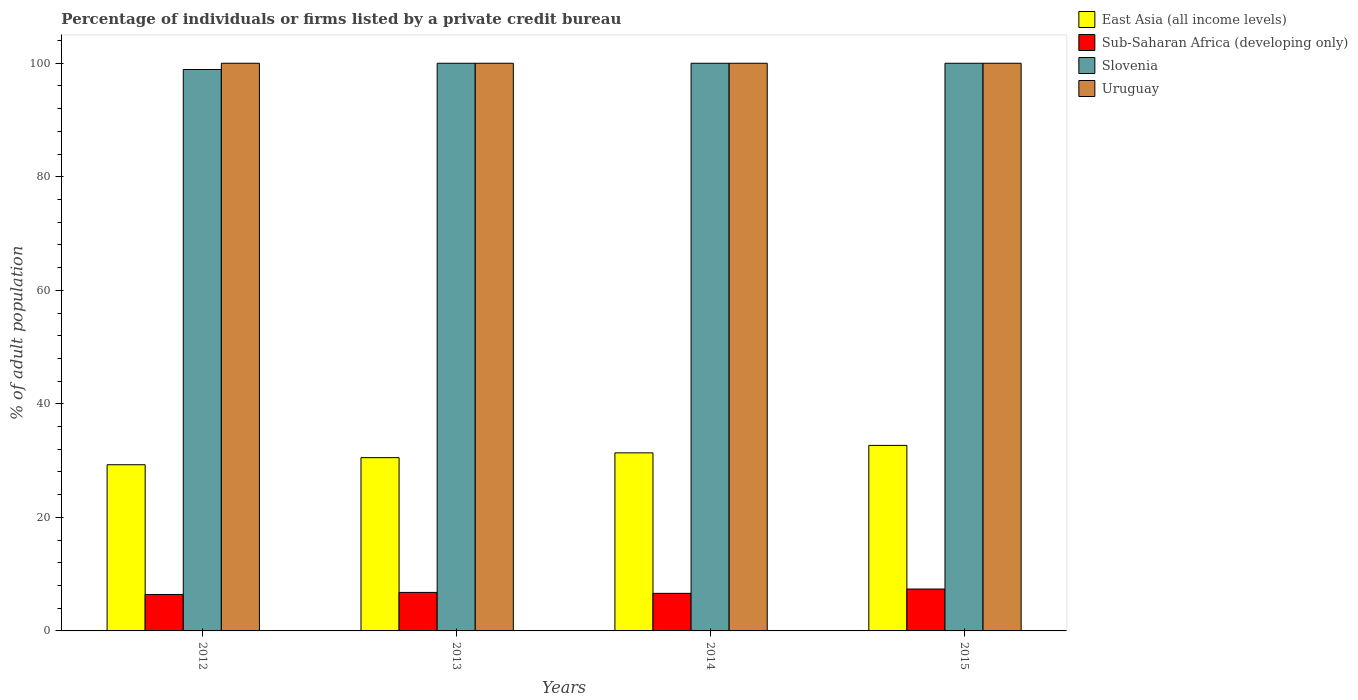How many groups of bars are there?
Provide a succinct answer. 4. Are the number of bars per tick equal to the number of legend labels?
Your answer should be very brief. Yes. How many bars are there on the 1st tick from the right?
Your response must be concise. 4. In how many cases, is the number of bars for a given year not equal to the number of legend labels?
Offer a terse response. 0. What is the percentage of population listed by a private credit bureau in Slovenia in 2014?
Provide a short and direct response. 100. Across all years, what is the minimum percentage of population listed by a private credit bureau in Slovenia?
Offer a terse response. 98.9. What is the total percentage of population listed by a private credit bureau in East Asia (all income levels) in the graph?
Offer a very short reply. 123.85. What is the difference between the percentage of population listed by a private credit bureau in Sub-Saharan Africa (developing only) in 2012 and that in 2015?
Ensure brevity in your answer.  -0.96. What is the difference between the percentage of population listed by a private credit bureau in Uruguay in 2012 and the percentage of population listed by a private credit bureau in Slovenia in 2013?
Offer a very short reply. 0. What is the average percentage of population listed by a private credit bureau in Sub-Saharan Africa (developing only) per year?
Your response must be concise. 6.8. In the year 2014, what is the difference between the percentage of population listed by a private credit bureau in Uruguay and percentage of population listed by a private credit bureau in Sub-Saharan Africa (developing only)?
Your response must be concise. 93.38. In how many years, is the percentage of population listed by a private credit bureau in Slovenia greater than 80 %?
Your answer should be compact. 4. What is the ratio of the percentage of population listed by a private credit bureau in Sub-Saharan Africa (developing only) in 2012 to that in 2015?
Your answer should be compact. 0.87. What is the difference between the highest and the lowest percentage of population listed by a private credit bureau in East Asia (all income levels)?
Give a very brief answer. 3.41. Is it the case that in every year, the sum of the percentage of population listed by a private credit bureau in Slovenia and percentage of population listed by a private credit bureau in Sub-Saharan Africa (developing only) is greater than the sum of percentage of population listed by a private credit bureau in Uruguay and percentage of population listed by a private credit bureau in East Asia (all income levels)?
Offer a terse response. Yes. What does the 4th bar from the left in 2015 represents?
Give a very brief answer. Uruguay. What does the 4th bar from the right in 2012 represents?
Keep it short and to the point. East Asia (all income levels). How many bars are there?
Your answer should be very brief. 16. How many years are there in the graph?
Provide a succinct answer. 4. What is the difference between two consecutive major ticks on the Y-axis?
Provide a succinct answer. 20. Are the values on the major ticks of Y-axis written in scientific E-notation?
Your answer should be compact. No. Does the graph contain any zero values?
Ensure brevity in your answer.  No. Does the graph contain grids?
Your answer should be compact. No. Where does the legend appear in the graph?
Offer a terse response. Top right. How many legend labels are there?
Provide a short and direct response. 4. What is the title of the graph?
Offer a very short reply. Percentage of individuals or firms listed by a private credit bureau. What is the label or title of the Y-axis?
Your response must be concise. % of adult population. What is the % of adult population in East Asia (all income levels) in 2012?
Your answer should be very brief. 29.28. What is the % of adult population in Sub-Saharan Africa (developing only) in 2012?
Give a very brief answer. 6.42. What is the % of adult population in Slovenia in 2012?
Offer a very short reply. 98.9. What is the % of adult population in Uruguay in 2012?
Your response must be concise. 100. What is the % of adult population of East Asia (all income levels) in 2013?
Provide a short and direct response. 30.52. What is the % of adult population of Sub-Saharan Africa (developing only) in 2013?
Your answer should be compact. 6.78. What is the % of adult population of Slovenia in 2013?
Ensure brevity in your answer.  100. What is the % of adult population of Uruguay in 2013?
Your response must be concise. 100. What is the % of adult population of East Asia (all income levels) in 2014?
Your answer should be very brief. 31.37. What is the % of adult population in Sub-Saharan Africa (developing only) in 2014?
Keep it short and to the point. 6.62. What is the % of adult population in Slovenia in 2014?
Ensure brevity in your answer.  100. What is the % of adult population in Uruguay in 2014?
Make the answer very short. 100. What is the % of adult population in East Asia (all income levels) in 2015?
Offer a very short reply. 32.68. What is the % of adult population of Sub-Saharan Africa (developing only) in 2015?
Provide a short and direct response. 7.38. What is the % of adult population in Slovenia in 2015?
Make the answer very short. 100. Across all years, what is the maximum % of adult population of East Asia (all income levels)?
Give a very brief answer. 32.68. Across all years, what is the maximum % of adult population in Sub-Saharan Africa (developing only)?
Your response must be concise. 7.38. Across all years, what is the maximum % of adult population in Slovenia?
Offer a very short reply. 100. Across all years, what is the minimum % of adult population of East Asia (all income levels)?
Ensure brevity in your answer.  29.28. Across all years, what is the minimum % of adult population of Sub-Saharan Africa (developing only)?
Give a very brief answer. 6.42. Across all years, what is the minimum % of adult population of Slovenia?
Provide a succinct answer. 98.9. Across all years, what is the minimum % of adult population in Uruguay?
Give a very brief answer. 100. What is the total % of adult population in East Asia (all income levels) in the graph?
Your answer should be compact. 123.85. What is the total % of adult population of Sub-Saharan Africa (developing only) in the graph?
Make the answer very short. 27.2. What is the total % of adult population in Slovenia in the graph?
Ensure brevity in your answer.  398.9. What is the difference between the % of adult population in East Asia (all income levels) in 2012 and that in 2013?
Give a very brief answer. -1.25. What is the difference between the % of adult population in Sub-Saharan Africa (developing only) in 2012 and that in 2013?
Keep it short and to the point. -0.36. What is the difference between the % of adult population in Uruguay in 2012 and that in 2013?
Provide a short and direct response. 0. What is the difference between the % of adult population in East Asia (all income levels) in 2012 and that in 2014?
Give a very brief answer. -2.09. What is the difference between the % of adult population of Sub-Saharan Africa (developing only) in 2012 and that in 2014?
Provide a short and direct response. -0.2. What is the difference between the % of adult population of Slovenia in 2012 and that in 2014?
Offer a very short reply. -1.1. What is the difference between the % of adult population of Uruguay in 2012 and that in 2014?
Provide a succinct answer. 0. What is the difference between the % of adult population of East Asia (all income levels) in 2012 and that in 2015?
Give a very brief answer. -3.41. What is the difference between the % of adult population of Sub-Saharan Africa (developing only) in 2012 and that in 2015?
Provide a short and direct response. -0.96. What is the difference between the % of adult population of East Asia (all income levels) in 2013 and that in 2014?
Your answer should be very brief. -0.84. What is the difference between the % of adult population in Sub-Saharan Africa (developing only) in 2013 and that in 2014?
Your response must be concise. 0.16. What is the difference between the % of adult population in Slovenia in 2013 and that in 2014?
Provide a short and direct response. 0. What is the difference between the % of adult population in East Asia (all income levels) in 2013 and that in 2015?
Your answer should be very brief. -2.16. What is the difference between the % of adult population of Sub-Saharan Africa (developing only) in 2013 and that in 2015?
Keep it short and to the point. -0.6. What is the difference between the % of adult population in Uruguay in 2013 and that in 2015?
Make the answer very short. 0. What is the difference between the % of adult population in East Asia (all income levels) in 2014 and that in 2015?
Your answer should be compact. -1.31. What is the difference between the % of adult population in Sub-Saharan Africa (developing only) in 2014 and that in 2015?
Your answer should be compact. -0.76. What is the difference between the % of adult population in Slovenia in 2014 and that in 2015?
Ensure brevity in your answer.  0. What is the difference between the % of adult population in Uruguay in 2014 and that in 2015?
Make the answer very short. 0. What is the difference between the % of adult population in East Asia (all income levels) in 2012 and the % of adult population in Sub-Saharan Africa (developing only) in 2013?
Your answer should be compact. 22.49. What is the difference between the % of adult population of East Asia (all income levels) in 2012 and the % of adult population of Slovenia in 2013?
Offer a terse response. -70.72. What is the difference between the % of adult population in East Asia (all income levels) in 2012 and the % of adult population in Uruguay in 2013?
Provide a succinct answer. -70.72. What is the difference between the % of adult population in Sub-Saharan Africa (developing only) in 2012 and the % of adult population in Slovenia in 2013?
Your answer should be compact. -93.58. What is the difference between the % of adult population in Sub-Saharan Africa (developing only) in 2012 and the % of adult population in Uruguay in 2013?
Provide a short and direct response. -93.58. What is the difference between the % of adult population of East Asia (all income levels) in 2012 and the % of adult population of Sub-Saharan Africa (developing only) in 2014?
Your answer should be compact. 22.66. What is the difference between the % of adult population in East Asia (all income levels) in 2012 and the % of adult population in Slovenia in 2014?
Provide a short and direct response. -70.72. What is the difference between the % of adult population in East Asia (all income levels) in 2012 and the % of adult population in Uruguay in 2014?
Your answer should be compact. -70.72. What is the difference between the % of adult population of Sub-Saharan Africa (developing only) in 2012 and the % of adult population of Slovenia in 2014?
Your response must be concise. -93.58. What is the difference between the % of adult population of Sub-Saharan Africa (developing only) in 2012 and the % of adult population of Uruguay in 2014?
Give a very brief answer. -93.58. What is the difference between the % of adult population in Slovenia in 2012 and the % of adult population in Uruguay in 2014?
Give a very brief answer. -1.1. What is the difference between the % of adult population of East Asia (all income levels) in 2012 and the % of adult population of Sub-Saharan Africa (developing only) in 2015?
Your answer should be compact. 21.9. What is the difference between the % of adult population in East Asia (all income levels) in 2012 and the % of adult population in Slovenia in 2015?
Keep it short and to the point. -70.72. What is the difference between the % of adult population of East Asia (all income levels) in 2012 and the % of adult population of Uruguay in 2015?
Provide a short and direct response. -70.72. What is the difference between the % of adult population in Sub-Saharan Africa (developing only) in 2012 and the % of adult population in Slovenia in 2015?
Make the answer very short. -93.58. What is the difference between the % of adult population of Sub-Saharan Africa (developing only) in 2012 and the % of adult population of Uruguay in 2015?
Ensure brevity in your answer.  -93.58. What is the difference between the % of adult population of Slovenia in 2012 and the % of adult population of Uruguay in 2015?
Give a very brief answer. -1.1. What is the difference between the % of adult population in East Asia (all income levels) in 2013 and the % of adult population in Sub-Saharan Africa (developing only) in 2014?
Provide a succinct answer. 23.91. What is the difference between the % of adult population of East Asia (all income levels) in 2013 and the % of adult population of Slovenia in 2014?
Offer a terse response. -69.48. What is the difference between the % of adult population in East Asia (all income levels) in 2013 and the % of adult population in Uruguay in 2014?
Make the answer very short. -69.48. What is the difference between the % of adult population of Sub-Saharan Africa (developing only) in 2013 and the % of adult population of Slovenia in 2014?
Your answer should be very brief. -93.22. What is the difference between the % of adult population in Sub-Saharan Africa (developing only) in 2013 and the % of adult population in Uruguay in 2014?
Your answer should be compact. -93.22. What is the difference between the % of adult population in East Asia (all income levels) in 2013 and the % of adult population in Sub-Saharan Africa (developing only) in 2015?
Your answer should be compact. 23.14. What is the difference between the % of adult population of East Asia (all income levels) in 2013 and the % of adult population of Slovenia in 2015?
Make the answer very short. -69.48. What is the difference between the % of adult population in East Asia (all income levels) in 2013 and the % of adult population in Uruguay in 2015?
Your response must be concise. -69.48. What is the difference between the % of adult population in Sub-Saharan Africa (developing only) in 2013 and the % of adult population in Slovenia in 2015?
Give a very brief answer. -93.22. What is the difference between the % of adult population in Sub-Saharan Africa (developing only) in 2013 and the % of adult population in Uruguay in 2015?
Provide a succinct answer. -93.22. What is the difference between the % of adult population in East Asia (all income levels) in 2014 and the % of adult population in Sub-Saharan Africa (developing only) in 2015?
Your response must be concise. 23.99. What is the difference between the % of adult population of East Asia (all income levels) in 2014 and the % of adult population of Slovenia in 2015?
Keep it short and to the point. -68.63. What is the difference between the % of adult population of East Asia (all income levels) in 2014 and the % of adult population of Uruguay in 2015?
Provide a succinct answer. -68.63. What is the difference between the % of adult population in Sub-Saharan Africa (developing only) in 2014 and the % of adult population in Slovenia in 2015?
Ensure brevity in your answer.  -93.38. What is the difference between the % of adult population of Sub-Saharan Africa (developing only) in 2014 and the % of adult population of Uruguay in 2015?
Make the answer very short. -93.38. What is the difference between the % of adult population in Slovenia in 2014 and the % of adult population in Uruguay in 2015?
Give a very brief answer. 0. What is the average % of adult population in East Asia (all income levels) per year?
Offer a very short reply. 30.96. What is the average % of adult population of Sub-Saharan Africa (developing only) per year?
Your answer should be compact. 6.8. What is the average % of adult population of Slovenia per year?
Provide a succinct answer. 99.72. In the year 2012, what is the difference between the % of adult population of East Asia (all income levels) and % of adult population of Sub-Saharan Africa (developing only)?
Give a very brief answer. 22.86. In the year 2012, what is the difference between the % of adult population of East Asia (all income levels) and % of adult population of Slovenia?
Your answer should be compact. -69.62. In the year 2012, what is the difference between the % of adult population in East Asia (all income levels) and % of adult population in Uruguay?
Make the answer very short. -70.72. In the year 2012, what is the difference between the % of adult population in Sub-Saharan Africa (developing only) and % of adult population in Slovenia?
Keep it short and to the point. -92.48. In the year 2012, what is the difference between the % of adult population of Sub-Saharan Africa (developing only) and % of adult population of Uruguay?
Ensure brevity in your answer.  -93.58. In the year 2013, what is the difference between the % of adult population in East Asia (all income levels) and % of adult population in Sub-Saharan Africa (developing only)?
Offer a very short reply. 23.74. In the year 2013, what is the difference between the % of adult population of East Asia (all income levels) and % of adult population of Slovenia?
Your response must be concise. -69.48. In the year 2013, what is the difference between the % of adult population in East Asia (all income levels) and % of adult population in Uruguay?
Offer a terse response. -69.48. In the year 2013, what is the difference between the % of adult population of Sub-Saharan Africa (developing only) and % of adult population of Slovenia?
Your answer should be compact. -93.22. In the year 2013, what is the difference between the % of adult population in Sub-Saharan Africa (developing only) and % of adult population in Uruguay?
Your answer should be very brief. -93.22. In the year 2013, what is the difference between the % of adult population of Slovenia and % of adult population of Uruguay?
Offer a terse response. 0. In the year 2014, what is the difference between the % of adult population of East Asia (all income levels) and % of adult population of Sub-Saharan Africa (developing only)?
Your answer should be very brief. 24.75. In the year 2014, what is the difference between the % of adult population of East Asia (all income levels) and % of adult population of Slovenia?
Make the answer very short. -68.63. In the year 2014, what is the difference between the % of adult population in East Asia (all income levels) and % of adult population in Uruguay?
Offer a terse response. -68.63. In the year 2014, what is the difference between the % of adult population of Sub-Saharan Africa (developing only) and % of adult population of Slovenia?
Your response must be concise. -93.38. In the year 2014, what is the difference between the % of adult population in Sub-Saharan Africa (developing only) and % of adult population in Uruguay?
Your answer should be very brief. -93.38. In the year 2014, what is the difference between the % of adult population of Slovenia and % of adult population of Uruguay?
Keep it short and to the point. 0. In the year 2015, what is the difference between the % of adult population in East Asia (all income levels) and % of adult population in Sub-Saharan Africa (developing only)?
Offer a very short reply. 25.3. In the year 2015, what is the difference between the % of adult population in East Asia (all income levels) and % of adult population in Slovenia?
Ensure brevity in your answer.  -67.32. In the year 2015, what is the difference between the % of adult population in East Asia (all income levels) and % of adult population in Uruguay?
Provide a succinct answer. -67.32. In the year 2015, what is the difference between the % of adult population of Sub-Saharan Africa (developing only) and % of adult population of Slovenia?
Keep it short and to the point. -92.62. In the year 2015, what is the difference between the % of adult population in Sub-Saharan Africa (developing only) and % of adult population in Uruguay?
Provide a succinct answer. -92.62. In the year 2015, what is the difference between the % of adult population in Slovenia and % of adult population in Uruguay?
Provide a succinct answer. 0. What is the ratio of the % of adult population of East Asia (all income levels) in 2012 to that in 2013?
Your answer should be compact. 0.96. What is the ratio of the % of adult population in Sub-Saharan Africa (developing only) in 2012 to that in 2013?
Offer a very short reply. 0.95. What is the ratio of the % of adult population of Sub-Saharan Africa (developing only) in 2012 to that in 2014?
Make the answer very short. 0.97. What is the ratio of the % of adult population in Uruguay in 2012 to that in 2014?
Offer a very short reply. 1. What is the ratio of the % of adult population in East Asia (all income levels) in 2012 to that in 2015?
Ensure brevity in your answer.  0.9. What is the ratio of the % of adult population in Sub-Saharan Africa (developing only) in 2012 to that in 2015?
Your response must be concise. 0.87. What is the ratio of the % of adult population of Slovenia in 2012 to that in 2015?
Your response must be concise. 0.99. What is the ratio of the % of adult population in Uruguay in 2012 to that in 2015?
Make the answer very short. 1. What is the ratio of the % of adult population in East Asia (all income levels) in 2013 to that in 2014?
Offer a very short reply. 0.97. What is the ratio of the % of adult population of Sub-Saharan Africa (developing only) in 2013 to that in 2014?
Offer a terse response. 1.02. What is the ratio of the % of adult population in Uruguay in 2013 to that in 2014?
Make the answer very short. 1. What is the ratio of the % of adult population in East Asia (all income levels) in 2013 to that in 2015?
Provide a short and direct response. 0.93. What is the ratio of the % of adult population in Sub-Saharan Africa (developing only) in 2013 to that in 2015?
Your response must be concise. 0.92. What is the ratio of the % of adult population of Slovenia in 2013 to that in 2015?
Make the answer very short. 1. What is the ratio of the % of adult population in East Asia (all income levels) in 2014 to that in 2015?
Provide a short and direct response. 0.96. What is the ratio of the % of adult population in Sub-Saharan Africa (developing only) in 2014 to that in 2015?
Offer a very short reply. 0.9. What is the ratio of the % of adult population in Slovenia in 2014 to that in 2015?
Provide a succinct answer. 1. What is the ratio of the % of adult population in Uruguay in 2014 to that in 2015?
Provide a short and direct response. 1. What is the difference between the highest and the second highest % of adult population in East Asia (all income levels)?
Give a very brief answer. 1.31. What is the difference between the highest and the second highest % of adult population in Sub-Saharan Africa (developing only)?
Provide a succinct answer. 0.6. What is the difference between the highest and the second highest % of adult population of Uruguay?
Your response must be concise. 0. What is the difference between the highest and the lowest % of adult population in East Asia (all income levels)?
Make the answer very short. 3.41. What is the difference between the highest and the lowest % of adult population of Sub-Saharan Africa (developing only)?
Offer a very short reply. 0.96. 